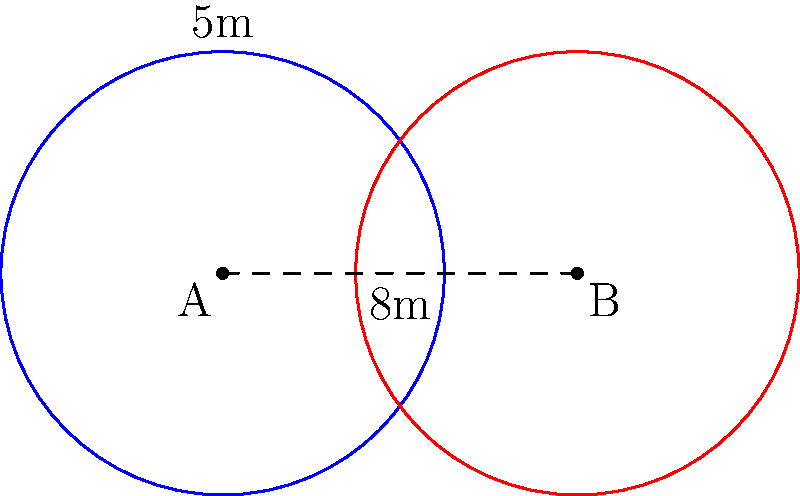In a large office space, two Wi-Fi routers A and B are placed 8 meters apart. Each router has a circular coverage range with a radius of 5 meters. What is the area of the region covered by both routers, rounded to the nearest square meter? To find the area of overlap between two circles, we can use the following steps:

1. Calculate the distance between the centers (d):
   d = 8 meters (given in the question)

2. Calculate the radius (r):
   r = 5 meters (given in the question)

3. Check if the circles intersect:
   For intersection, d must be less than 2r
   8 < 2(5) = 10, so the circles do intersect

4. Calculate the angle θ (in radians) using the formula:
   $$θ = 2 \arccos(\frac{d}{2r})$$
   $$θ = 2 \arccos(\frac{8}{2(5)}) = 2 \arccos(0.8) ≈ 1.2870 \text{ radians}$$

5. Calculate the area of overlap using the formula:
   $$A = 2r^2 \arccos(\frac{d}{2r}) - d\sqrt{r^2 - (\frac{d}{2})^2}$$
   $$A = 2(5^2) \arccos(\frac{8}{2(5)}) - 8\sqrt{5^2 - (\frac{8}{2})^2}$$
   $$A = 50 \arccos(0.8) - 8\sqrt{25 - 16}$$
   $$A = 50(0.6435) - 8\sqrt{9}$$
   $$A = 32.175 - 24 = 8.175 \text{ square meters}$$

6. Round to the nearest square meter:
   8.175 ≈ 8 square meters
Answer: 8 square meters 